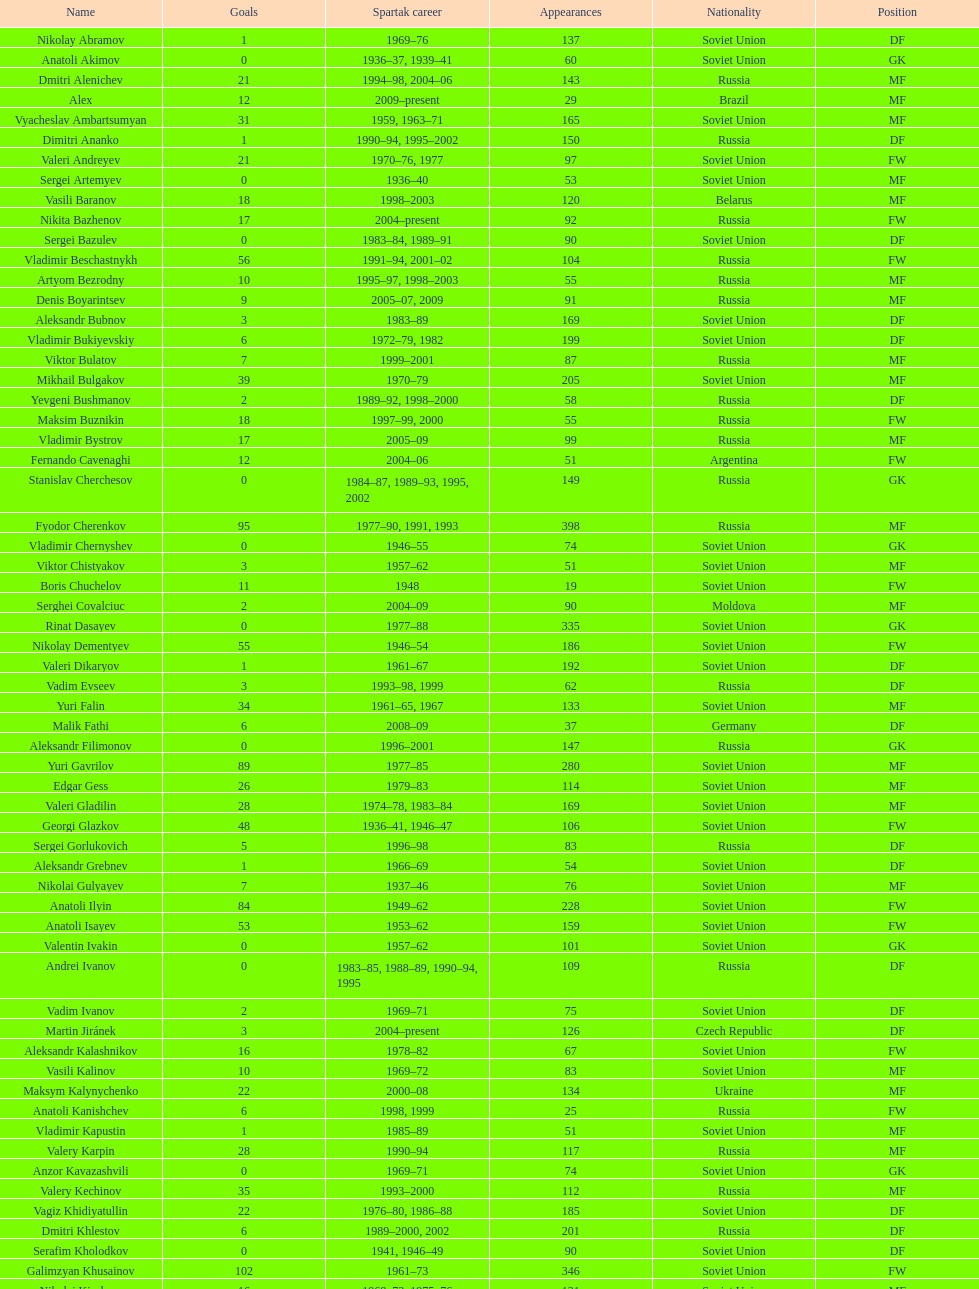Baranov has played from 2004 to the present. what is his nationality? Belarus. 